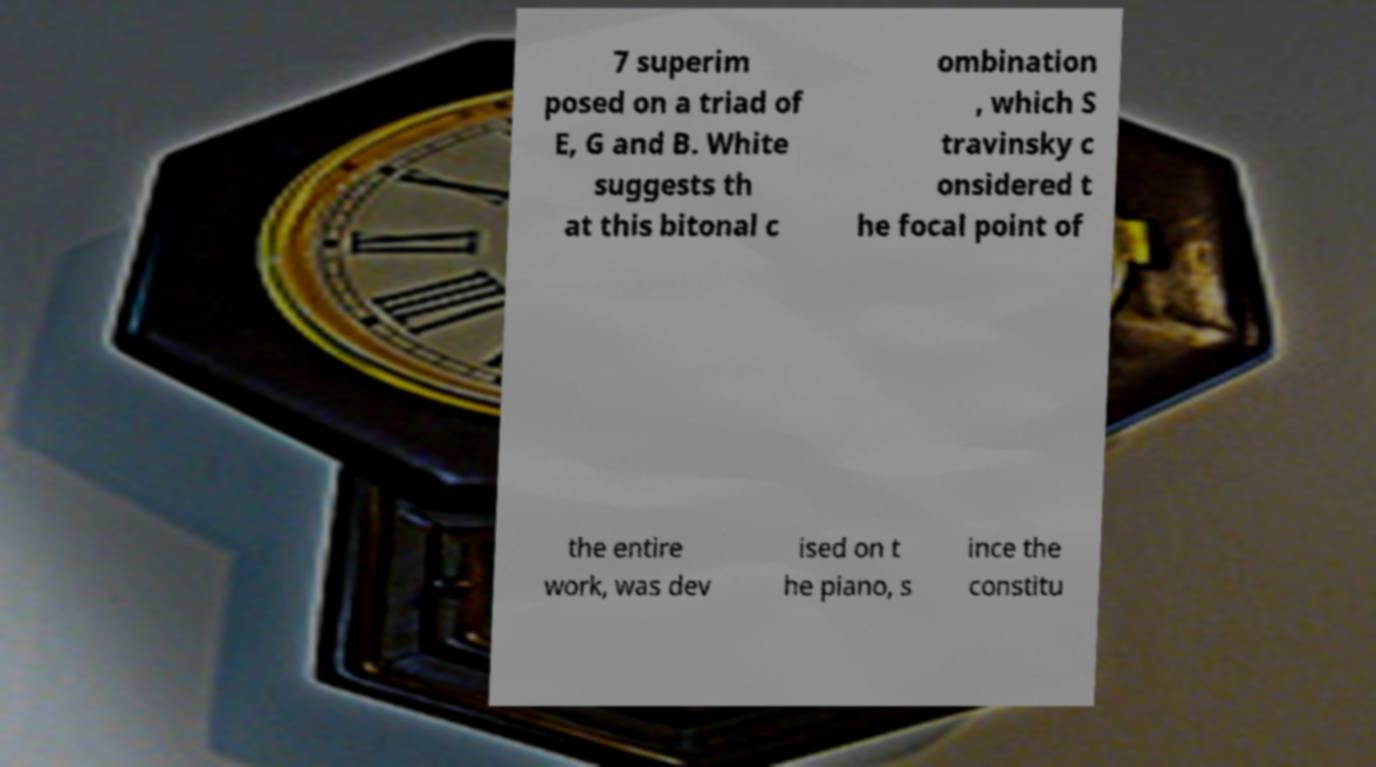For documentation purposes, I need the text within this image transcribed. Could you provide that? 7 superim posed on a triad of E, G and B. White suggests th at this bitonal c ombination , which S travinsky c onsidered t he focal point of the entire work, was dev ised on t he piano, s ince the constitu 